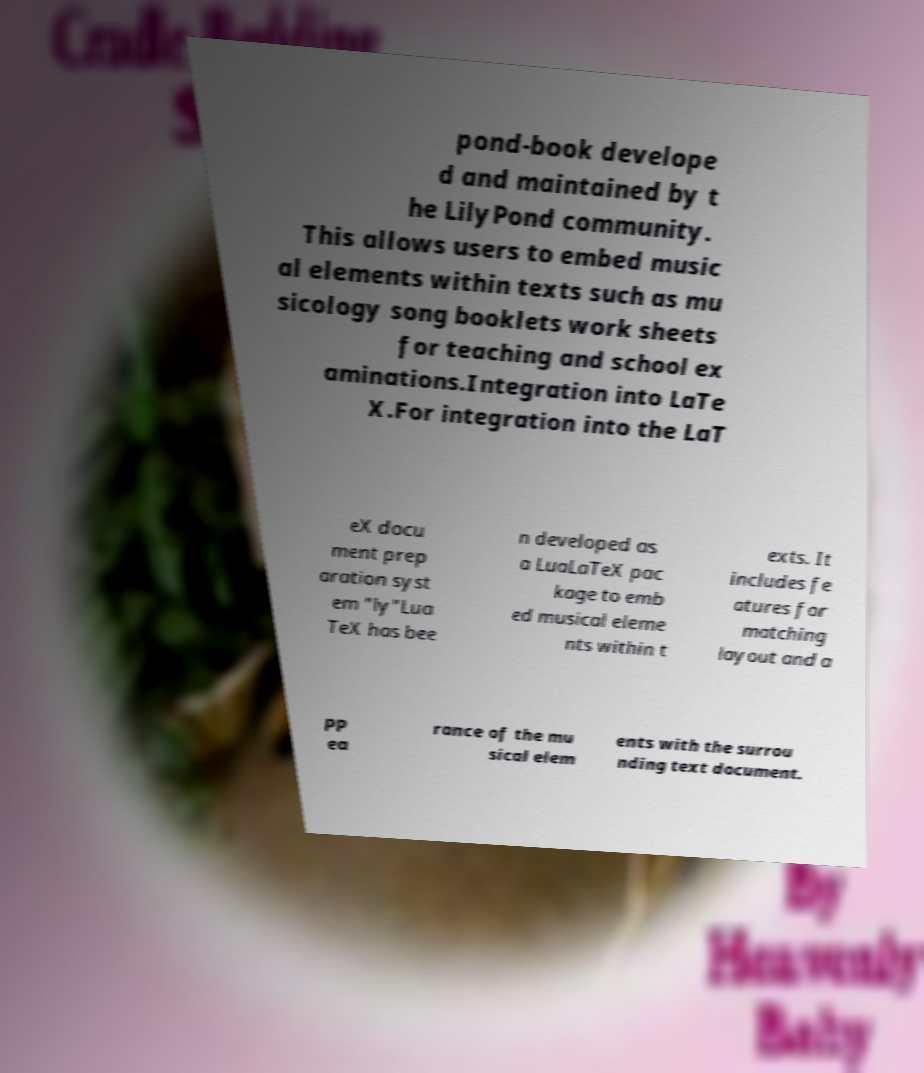Please identify and transcribe the text found in this image. pond-book develope d and maintained by t he LilyPond community. This allows users to embed music al elements within texts such as mu sicology song booklets work sheets for teaching and school ex aminations.Integration into LaTe X.For integration into the LaT eX docu ment prep aration syst em "ly"Lua TeX has bee n developed as a LuaLaTeX pac kage to emb ed musical eleme nts within t exts. It includes fe atures for matching layout and a pp ea rance of the mu sical elem ents with the surrou nding text document. 